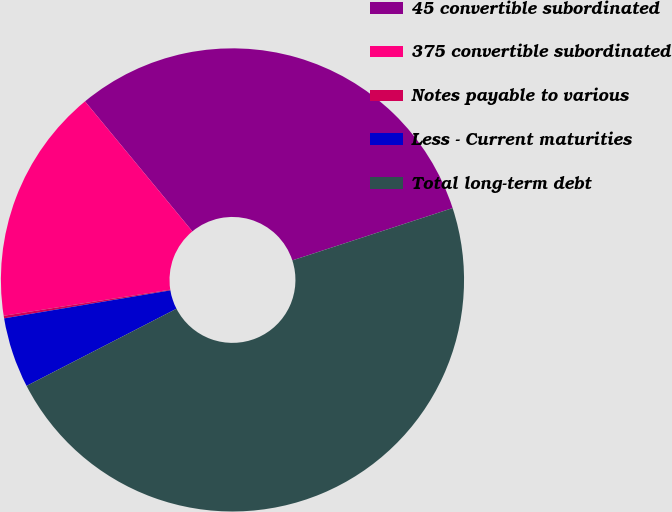Convert chart to OTSL. <chart><loc_0><loc_0><loc_500><loc_500><pie_chart><fcel>45 convertible subordinated<fcel>375 convertible subordinated<fcel>Notes payable to various<fcel>Less - Current maturities<fcel>Total long-term debt<nl><fcel>30.97%<fcel>16.49%<fcel>0.18%<fcel>4.91%<fcel>47.46%<nl></chart> 